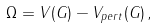<formula> <loc_0><loc_0><loc_500><loc_500>\Omega = V ( G ) - V _ { p e r t } ( G ) \, ,</formula> 